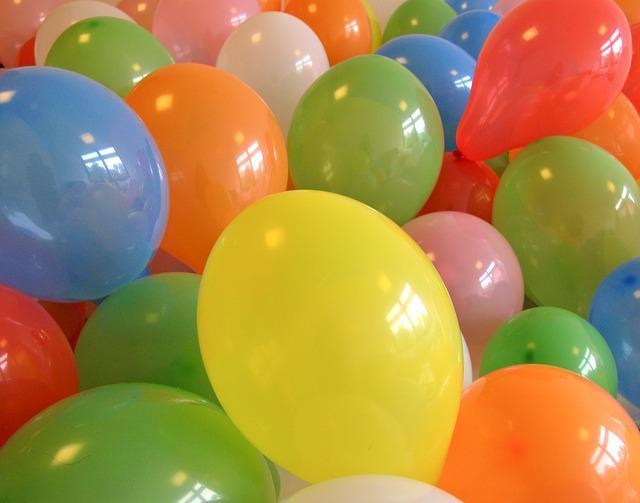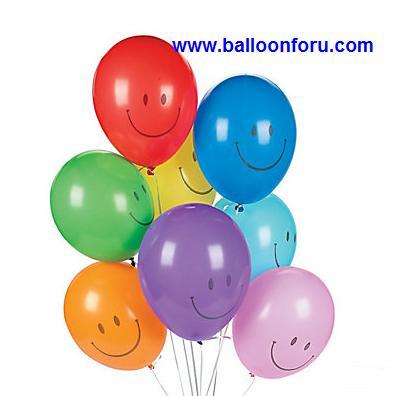The first image is the image on the left, the second image is the image on the right. Evaluate the accuracy of this statement regarding the images: "One image shows a bunch of balloons with gathered strings and curly ribbons under it, and the other image shows balloons trailing loose strings that don't hang straight.". Is it true? Answer yes or no. No. The first image is the image on the left, the second image is the image on the right. Analyze the images presented: Is the assertion "in at least one image there are at least fifteen loose balloons on strings." valid? Answer yes or no. No. 